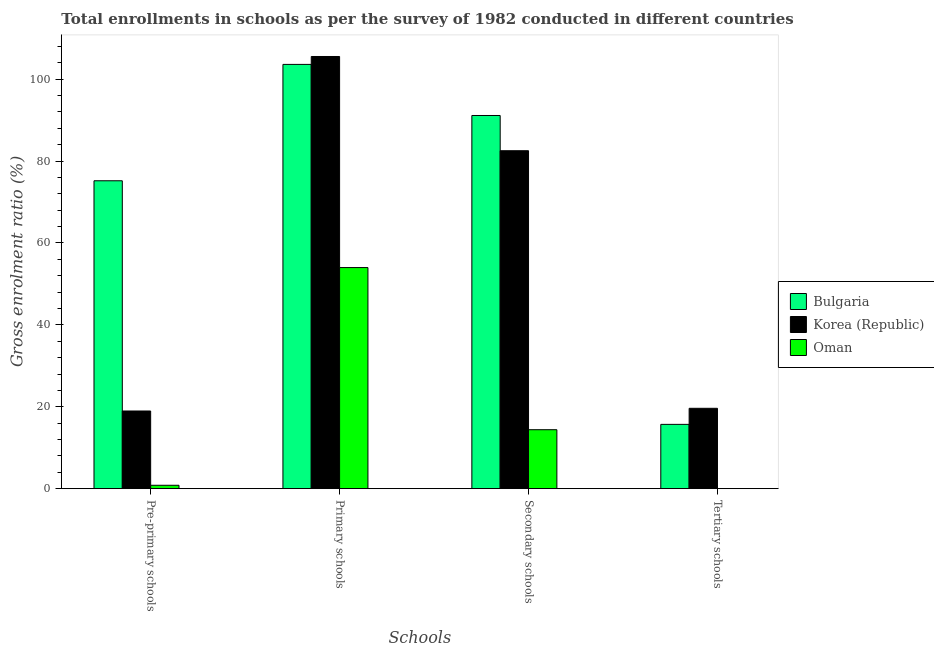Are the number of bars per tick equal to the number of legend labels?
Your answer should be very brief. Yes. How many bars are there on the 1st tick from the left?
Your answer should be very brief. 3. How many bars are there on the 2nd tick from the right?
Offer a terse response. 3. What is the label of the 1st group of bars from the left?
Make the answer very short. Pre-primary schools. What is the gross enrolment ratio in pre-primary schools in Bulgaria?
Your answer should be compact. 75.18. Across all countries, what is the maximum gross enrolment ratio in pre-primary schools?
Provide a succinct answer. 75.18. Across all countries, what is the minimum gross enrolment ratio in tertiary schools?
Make the answer very short. 0.01. In which country was the gross enrolment ratio in tertiary schools minimum?
Your answer should be very brief. Oman. What is the total gross enrolment ratio in pre-primary schools in the graph?
Your answer should be very brief. 94.98. What is the difference between the gross enrolment ratio in secondary schools in Korea (Republic) and that in Oman?
Provide a succinct answer. 68.13. What is the difference between the gross enrolment ratio in secondary schools in Bulgaria and the gross enrolment ratio in tertiary schools in Oman?
Your answer should be compact. 91.11. What is the average gross enrolment ratio in primary schools per country?
Make the answer very short. 87.71. What is the difference between the gross enrolment ratio in primary schools and gross enrolment ratio in secondary schools in Korea (Republic)?
Offer a terse response. 23.01. What is the ratio of the gross enrolment ratio in secondary schools in Korea (Republic) to that in Bulgaria?
Provide a short and direct response. 0.91. Is the gross enrolment ratio in secondary schools in Oman less than that in Korea (Republic)?
Keep it short and to the point. Yes. Is the difference between the gross enrolment ratio in secondary schools in Korea (Republic) and Oman greater than the difference between the gross enrolment ratio in tertiary schools in Korea (Republic) and Oman?
Your response must be concise. Yes. What is the difference between the highest and the second highest gross enrolment ratio in secondary schools?
Offer a terse response. 8.6. What is the difference between the highest and the lowest gross enrolment ratio in secondary schools?
Offer a very short reply. 76.73. In how many countries, is the gross enrolment ratio in primary schools greater than the average gross enrolment ratio in primary schools taken over all countries?
Give a very brief answer. 2. Is the sum of the gross enrolment ratio in primary schools in Bulgaria and Korea (Republic) greater than the maximum gross enrolment ratio in secondary schools across all countries?
Make the answer very short. Yes. What does the 3rd bar from the left in Tertiary schools represents?
Provide a short and direct response. Oman. Is it the case that in every country, the sum of the gross enrolment ratio in pre-primary schools and gross enrolment ratio in primary schools is greater than the gross enrolment ratio in secondary schools?
Ensure brevity in your answer.  Yes. How many bars are there?
Provide a short and direct response. 12. How many countries are there in the graph?
Your answer should be very brief. 3. How many legend labels are there?
Give a very brief answer. 3. How are the legend labels stacked?
Provide a succinct answer. Vertical. What is the title of the graph?
Your answer should be very brief. Total enrollments in schools as per the survey of 1982 conducted in different countries. What is the label or title of the X-axis?
Offer a terse response. Schools. What is the Gross enrolment ratio (%) of Bulgaria in Pre-primary schools?
Your answer should be compact. 75.18. What is the Gross enrolment ratio (%) in Korea (Republic) in Pre-primary schools?
Offer a very short reply. 18.97. What is the Gross enrolment ratio (%) in Oman in Pre-primary schools?
Offer a very short reply. 0.83. What is the Gross enrolment ratio (%) in Bulgaria in Primary schools?
Make the answer very short. 103.6. What is the Gross enrolment ratio (%) in Korea (Republic) in Primary schools?
Provide a succinct answer. 105.53. What is the Gross enrolment ratio (%) of Oman in Primary schools?
Keep it short and to the point. 53.99. What is the Gross enrolment ratio (%) of Bulgaria in Secondary schools?
Your answer should be very brief. 91.13. What is the Gross enrolment ratio (%) of Korea (Republic) in Secondary schools?
Keep it short and to the point. 82.52. What is the Gross enrolment ratio (%) of Oman in Secondary schools?
Provide a short and direct response. 14.4. What is the Gross enrolment ratio (%) in Bulgaria in Tertiary schools?
Offer a very short reply. 15.7. What is the Gross enrolment ratio (%) of Korea (Republic) in Tertiary schools?
Provide a succinct answer. 19.62. What is the Gross enrolment ratio (%) of Oman in Tertiary schools?
Make the answer very short. 0.01. Across all Schools, what is the maximum Gross enrolment ratio (%) of Bulgaria?
Keep it short and to the point. 103.6. Across all Schools, what is the maximum Gross enrolment ratio (%) of Korea (Republic)?
Give a very brief answer. 105.53. Across all Schools, what is the maximum Gross enrolment ratio (%) of Oman?
Give a very brief answer. 53.99. Across all Schools, what is the minimum Gross enrolment ratio (%) of Bulgaria?
Keep it short and to the point. 15.7. Across all Schools, what is the minimum Gross enrolment ratio (%) of Korea (Republic)?
Your answer should be compact. 18.97. Across all Schools, what is the minimum Gross enrolment ratio (%) of Oman?
Keep it short and to the point. 0.01. What is the total Gross enrolment ratio (%) of Bulgaria in the graph?
Your answer should be very brief. 285.61. What is the total Gross enrolment ratio (%) of Korea (Republic) in the graph?
Provide a short and direct response. 226.65. What is the total Gross enrolment ratio (%) in Oman in the graph?
Offer a terse response. 69.23. What is the difference between the Gross enrolment ratio (%) of Bulgaria in Pre-primary schools and that in Primary schools?
Your answer should be compact. -28.42. What is the difference between the Gross enrolment ratio (%) in Korea (Republic) in Pre-primary schools and that in Primary schools?
Keep it short and to the point. -86.56. What is the difference between the Gross enrolment ratio (%) in Oman in Pre-primary schools and that in Primary schools?
Keep it short and to the point. -53.16. What is the difference between the Gross enrolment ratio (%) in Bulgaria in Pre-primary schools and that in Secondary schools?
Make the answer very short. -15.94. What is the difference between the Gross enrolment ratio (%) in Korea (Republic) in Pre-primary schools and that in Secondary schools?
Your answer should be compact. -63.55. What is the difference between the Gross enrolment ratio (%) in Oman in Pre-primary schools and that in Secondary schools?
Provide a short and direct response. -13.56. What is the difference between the Gross enrolment ratio (%) of Bulgaria in Pre-primary schools and that in Tertiary schools?
Keep it short and to the point. 59.48. What is the difference between the Gross enrolment ratio (%) of Korea (Republic) in Pre-primary schools and that in Tertiary schools?
Your answer should be compact. -0.66. What is the difference between the Gross enrolment ratio (%) in Oman in Pre-primary schools and that in Tertiary schools?
Keep it short and to the point. 0.82. What is the difference between the Gross enrolment ratio (%) of Bulgaria in Primary schools and that in Secondary schools?
Keep it short and to the point. 12.47. What is the difference between the Gross enrolment ratio (%) of Korea (Republic) in Primary schools and that in Secondary schools?
Your answer should be very brief. 23.01. What is the difference between the Gross enrolment ratio (%) in Oman in Primary schools and that in Secondary schools?
Make the answer very short. 39.59. What is the difference between the Gross enrolment ratio (%) of Bulgaria in Primary schools and that in Tertiary schools?
Provide a succinct answer. 87.9. What is the difference between the Gross enrolment ratio (%) in Korea (Republic) in Primary schools and that in Tertiary schools?
Keep it short and to the point. 85.91. What is the difference between the Gross enrolment ratio (%) in Oman in Primary schools and that in Tertiary schools?
Your answer should be compact. 53.98. What is the difference between the Gross enrolment ratio (%) of Bulgaria in Secondary schools and that in Tertiary schools?
Offer a very short reply. 75.42. What is the difference between the Gross enrolment ratio (%) of Korea (Republic) in Secondary schools and that in Tertiary schools?
Offer a very short reply. 62.9. What is the difference between the Gross enrolment ratio (%) in Oman in Secondary schools and that in Tertiary schools?
Offer a very short reply. 14.38. What is the difference between the Gross enrolment ratio (%) in Bulgaria in Pre-primary schools and the Gross enrolment ratio (%) in Korea (Republic) in Primary schools?
Your answer should be compact. -30.35. What is the difference between the Gross enrolment ratio (%) of Bulgaria in Pre-primary schools and the Gross enrolment ratio (%) of Oman in Primary schools?
Your answer should be compact. 21.19. What is the difference between the Gross enrolment ratio (%) in Korea (Republic) in Pre-primary schools and the Gross enrolment ratio (%) in Oman in Primary schools?
Ensure brevity in your answer.  -35.02. What is the difference between the Gross enrolment ratio (%) of Bulgaria in Pre-primary schools and the Gross enrolment ratio (%) of Korea (Republic) in Secondary schools?
Provide a succinct answer. -7.34. What is the difference between the Gross enrolment ratio (%) in Bulgaria in Pre-primary schools and the Gross enrolment ratio (%) in Oman in Secondary schools?
Make the answer very short. 60.79. What is the difference between the Gross enrolment ratio (%) of Korea (Republic) in Pre-primary schools and the Gross enrolment ratio (%) of Oman in Secondary schools?
Offer a very short reply. 4.57. What is the difference between the Gross enrolment ratio (%) of Bulgaria in Pre-primary schools and the Gross enrolment ratio (%) of Korea (Republic) in Tertiary schools?
Give a very brief answer. 55.56. What is the difference between the Gross enrolment ratio (%) in Bulgaria in Pre-primary schools and the Gross enrolment ratio (%) in Oman in Tertiary schools?
Offer a very short reply. 75.17. What is the difference between the Gross enrolment ratio (%) of Korea (Republic) in Pre-primary schools and the Gross enrolment ratio (%) of Oman in Tertiary schools?
Give a very brief answer. 18.95. What is the difference between the Gross enrolment ratio (%) of Bulgaria in Primary schools and the Gross enrolment ratio (%) of Korea (Republic) in Secondary schools?
Offer a very short reply. 21.08. What is the difference between the Gross enrolment ratio (%) of Bulgaria in Primary schools and the Gross enrolment ratio (%) of Oman in Secondary schools?
Provide a succinct answer. 89.2. What is the difference between the Gross enrolment ratio (%) in Korea (Republic) in Primary schools and the Gross enrolment ratio (%) in Oman in Secondary schools?
Make the answer very short. 91.14. What is the difference between the Gross enrolment ratio (%) in Bulgaria in Primary schools and the Gross enrolment ratio (%) in Korea (Republic) in Tertiary schools?
Your answer should be very brief. 83.97. What is the difference between the Gross enrolment ratio (%) in Bulgaria in Primary schools and the Gross enrolment ratio (%) in Oman in Tertiary schools?
Provide a short and direct response. 103.59. What is the difference between the Gross enrolment ratio (%) in Korea (Republic) in Primary schools and the Gross enrolment ratio (%) in Oman in Tertiary schools?
Your answer should be very brief. 105.52. What is the difference between the Gross enrolment ratio (%) in Bulgaria in Secondary schools and the Gross enrolment ratio (%) in Korea (Republic) in Tertiary schools?
Ensure brevity in your answer.  71.5. What is the difference between the Gross enrolment ratio (%) in Bulgaria in Secondary schools and the Gross enrolment ratio (%) in Oman in Tertiary schools?
Offer a very short reply. 91.11. What is the difference between the Gross enrolment ratio (%) of Korea (Republic) in Secondary schools and the Gross enrolment ratio (%) of Oman in Tertiary schools?
Give a very brief answer. 82.51. What is the average Gross enrolment ratio (%) in Bulgaria per Schools?
Your answer should be compact. 71.4. What is the average Gross enrolment ratio (%) of Korea (Republic) per Schools?
Provide a short and direct response. 56.66. What is the average Gross enrolment ratio (%) in Oman per Schools?
Your response must be concise. 17.31. What is the difference between the Gross enrolment ratio (%) in Bulgaria and Gross enrolment ratio (%) in Korea (Republic) in Pre-primary schools?
Give a very brief answer. 56.22. What is the difference between the Gross enrolment ratio (%) of Bulgaria and Gross enrolment ratio (%) of Oman in Pre-primary schools?
Offer a terse response. 74.35. What is the difference between the Gross enrolment ratio (%) of Korea (Republic) and Gross enrolment ratio (%) of Oman in Pre-primary schools?
Your answer should be compact. 18.14. What is the difference between the Gross enrolment ratio (%) in Bulgaria and Gross enrolment ratio (%) in Korea (Republic) in Primary schools?
Keep it short and to the point. -1.93. What is the difference between the Gross enrolment ratio (%) in Bulgaria and Gross enrolment ratio (%) in Oman in Primary schools?
Your response must be concise. 49.61. What is the difference between the Gross enrolment ratio (%) in Korea (Republic) and Gross enrolment ratio (%) in Oman in Primary schools?
Provide a short and direct response. 51.54. What is the difference between the Gross enrolment ratio (%) in Bulgaria and Gross enrolment ratio (%) in Korea (Republic) in Secondary schools?
Provide a succinct answer. 8.6. What is the difference between the Gross enrolment ratio (%) in Bulgaria and Gross enrolment ratio (%) in Oman in Secondary schools?
Provide a succinct answer. 76.73. What is the difference between the Gross enrolment ratio (%) of Korea (Republic) and Gross enrolment ratio (%) of Oman in Secondary schools?
Offer a very short reply. 68.13. What is the difference between the Gross enrolment ratio (%) of Bulgaria and Gross enrolment ratio (%) of Korea (Republic) in Tertiary schools?
Your answer should be compact. -3.92. What is the difference between the Gross enrolment ratio (%) of Bulgaria and Gross enrolment ratio (%) of Oman in Tertiary schools?
Make the answer very short. 15.69. What is the difference between the Gross enrolment ratio (%) of Korea (Republic) and Gross enrolment ratio (%) of Oman in Tertiary schools?
Your response must be concise. 19.61. What is the ratio of the Gross enrolment ratio (%) in Bulgaria in Pre-primary schools to that in Primary schools?
Your answer should be very brief. 0.73. What is the ratio of the Gross enrolment ratio (%) in Korea (Republic) in Pre-primary schools to that in Primary schools?
Your answer should be very brief. 0.18. What is the ratio of the Gross enrolment ratio (%) of Oman in Pre-primary schools to that in Primary schools?
Offer a very short reply. 0.02. What is the ratio of the Gross enrolment ratio (%) in Bulgaria in Pre-primary schools to that in Secondary schools?
Keep it short and to the point. 0.83. What is the ratio of the Gross enrolment ratio (%) of Korea (Republic) in Pre-primary schools to that in Secondary schools?
Your answer should be compact. 0.23. What is the ratio of the Gross enrolment ratio (%) of Oman in Pre-primary schools to that in Secondary schools?
Your response must be concise. 0.06. What is the ratio of the Gross enrolment ratio (%) in Bulgaria in Pre-primary schools to that in Tertiary schools?
Offer a very short reply. 4.79. What is the ratio of the Gross enrolment ratio (%) in Korea (Republic) in Pre-primary schools to that in Tertiary schools?
Provide a succinct answer. 0.97. What is the ratio of the Gross enrolment ratio (%) in Oman in Pre-primary schools to that in Tertiary schools?
Provide a short and direct response. 62.08. What is the ratio of the Gross enrolment ratio (%) in Bulgaria in Primary schools to that in Secondary schools?
Keep it short and to the point. 1.14. What is the ratio of the Gross enrolment ratio (%) of Korea (Republic) in Primary schools to that in Secondary schools?
Offer a very short reply. 1.28. What is the ratio of the Gross enrolment ratio (%) of Oman in Primary schools to that in Secondary schools?
Give a very brief answer. 3.75. What is the ratio of the Gross enrolment ratio (%) of Bulgaria in Primary schools to that in Tertiary schools?
Ensure brevity in your answer.  6.6. What is the ratio of the Gross enrolment ratio (%) of Korea (Republic) in Primary schools to that in Tertiary schools?
Your response must be concise. 5.38. What is the ratio of the Gross enrolment ratio (%) in Oman in Primary schools to that in Tertiary schools?
Make the answer very short. 4029.17. What is the ratio of the Gross enrolment ratio (%) in Bulgaria in Secondary schools to that in Tertiary schools?
Provide a succinct answer. 5.8. What is the ratio of the Gross enrolment ratio (%) of Korea (Republic) in Secondary schools to that in Tertiary schools?
Provide a short and direct response. 4.21. What is the ratio of the Gross enrolment ratio (%) in Oman in Secondary schools to that in Tertiary schools?
Give a very brief answer. 1074.39. What is the difference between the highest and the second highest Gross enrolment ratio (%) of Bulgaria?
Keep it short and to the point. 12.47. What is the difference between the highest and the second highest Gross enrolment ratio (%) of Korea (Republic)?
Your answer should be very brief. 23.01. What is the difference between the highest and the second highest Gross enrolment ratio (%) of Oman?
Your response must be concise. 39.59. What is the difference between the highest and the lowest Gross enrolment ratio (%) of Bulgaria?
Ensure brevity in your answer.  87.9. What is the difference between the highest and the lowest Gross enrolment ratio (%) of Korea (Republic)?
Ensure brevity in your answer.  86.56. What is the difference between the highest and the lowest Gross enrolment ratio (%) of Oman?
Provide a short and direct response. 53.98. 